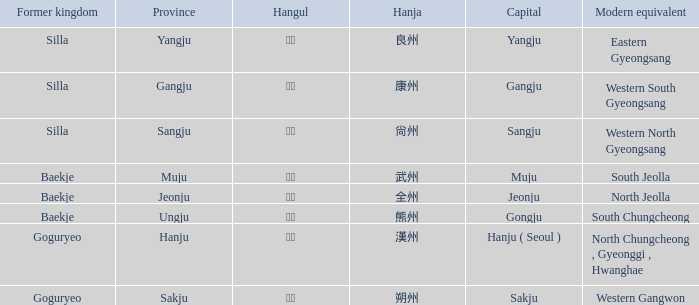The hanja 尙州 is for what capital? Sangju. 